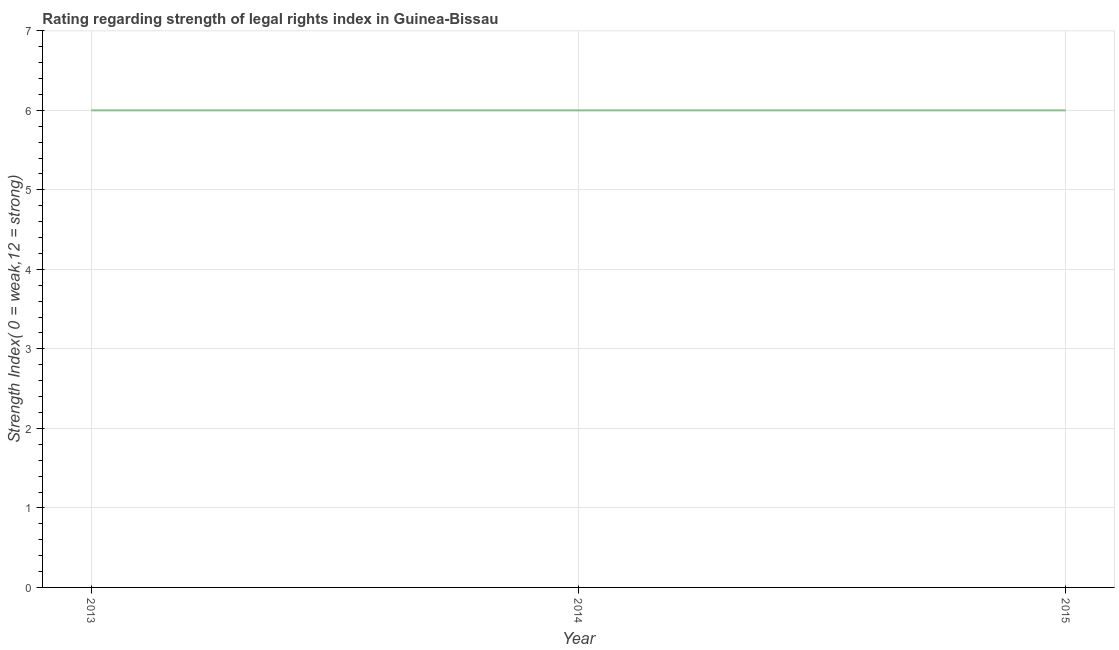What is the strength of legal rights index in 2013?
Offer a very short reply. 6. Across all years, what is the minimum strength of legal rights index?
Provide a short and direct response. 6. In which year was the strength of legal rights index maximum?
Offer a terse response. 2013. What is the sum of the strength of legal rights index?
Your answer should be compact. 18. In how many years, is the strength of legal rights index greater than 1 ?
Offer a very short reply. 3. What is the ratio of the strength of legal rights index in 2013 to that in 2014?
Make the answer very short. 1. Is the strength of legal rights index in 2013 less than that in 2014?
Your answer should be very brief. No. Is the difference between the strength of legal rights index in 2013 and 2014 greater than the difference between any two years?
Keep it short and to the point. Yes. Is the sum of the strength of legal rights index in 2013 and 2014 greater than the maximum strength of legal rights index across all years?
Your answer should be very brief. Yes. What is the difference between the highest and the lowest strength of legal rights index?
Ensure brevity in your answer.  0. Does the strength of legal rights index monotonically increase over the years?
Your answer should be compact. No. How many lines are there?
Make the answer very short. 1. How many years are there in the graph?
Your response must be concise. 3. What is the difference between two consecutive major ticks on the Y-axis?
Offer a terse response. 1. Are the values on the major ticks of Y-axis written in scientific E-notation?
Your response must be concise. No. Does the graph contain grids?
Give a very brief answer. Yes. What is the title of the graph?
Your response must be concise. Rating regarding strength of legal rights index in Guinea-Bissau. What is the label or title of the X-axis?
Provide a short and direct response. Year. What is the label or title of the Y-axis?
Make the answer very short. Strength Index( 0 = weak,12 = strong). What is the Strength Index( 0 = weak,12 = strong) of 2013?
Offer a terse response. 6. What is the difference between the Strength Index( 0 = weak,12 = strong) in 2013 and 2014?
Provide a short and direct response. 0. What is the difference between the Strength Index( 0 = weak,12 = strong) in 2013 and 2015?
Your answer should be very brief. 0. What is the difference between the Strength Index( 0 = weak,12 = strong) in 2014 and 2015?
Your response must be concise. 0. What is the ratio of the Strength Index( 0 = weak,12 = strong) in 2014 to that in 2015?
Your response must be concise. 1. 